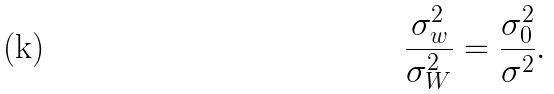Convert formula to latex. <formula><loc_0><loc_0><loc_500><loc_500>\frac { \sigma _ { w } ^ { 2 } } { \sigma _ { W } ^ { 2 } } = \frac { \sigma _ { 0 } ^ { 2 } } { \sigma ^ { 2 } } .</formula> 